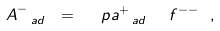<formula> <loc_0><loc_0><loc_500><loc_500>A ^ { - } _ { \, \ a d } \ = \ \ p a ^ { + } _ { \, \ a d } \ \ f ^ { - - } \ ,</formula> 